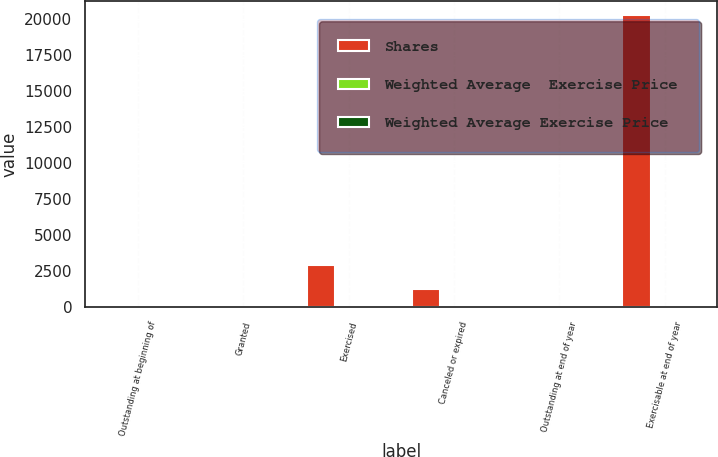Convert chart. <chart><loc_0><loc_0><loc_500><loc_500><stacked_bar_chart><ecel><fcel>Outstanding at beginning of<fcel>Granted<fcel>Exercised<fcel>Canceled or expired<fcel>Outstanding at end of year<fcel>Exercisable at end of year<nl><fcel>Shares<fcel>44.34<fcel>74<fcel>2973<fcel>1292<fcel>44.34<fcel>20290<nl><fcel>Weighted Average  Exercise Price<fcel>43.68<fcel>43.97<fcel>34.35<fcel>50.38<fcel>44.49<fcel>45.22<nl><fcel>Weighted Average Exercise Price<fcel>44.01<fcel>33.72<fcel>32.64<fcel>55.2<fcel>43.68<fcel>44.19<nl></chart> 